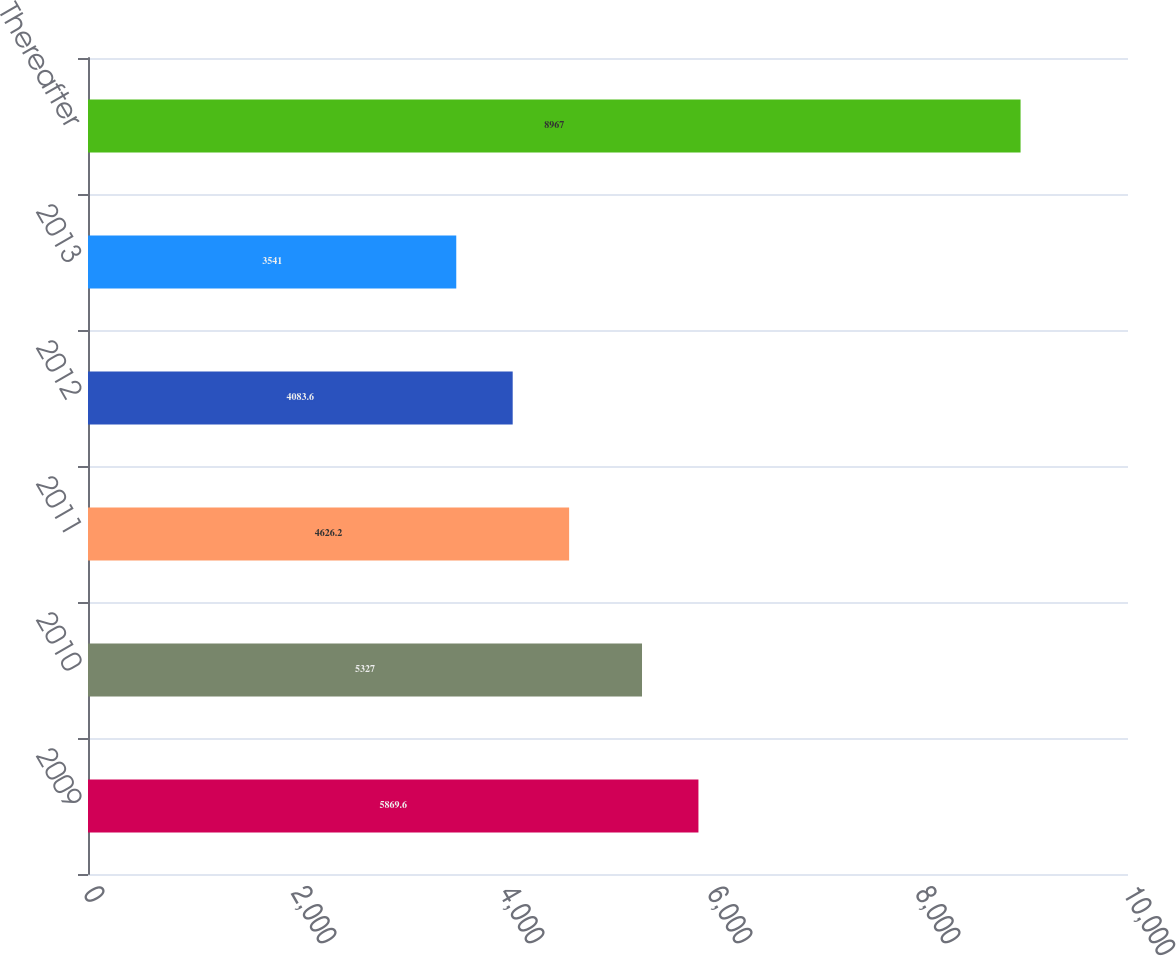<chart> <loc_0><loc_0><loc_500><loc_500><bar_chart><fcel>2009<fcel>2010<fcel>2011<fcel>2012<fcel>2013<fcel>Thereafter<nl><fcel>5869.6<fcel>5327<fcel>4626.2<fcel>4083.6<fcel>3541<fcel>8967<nl></chart> 